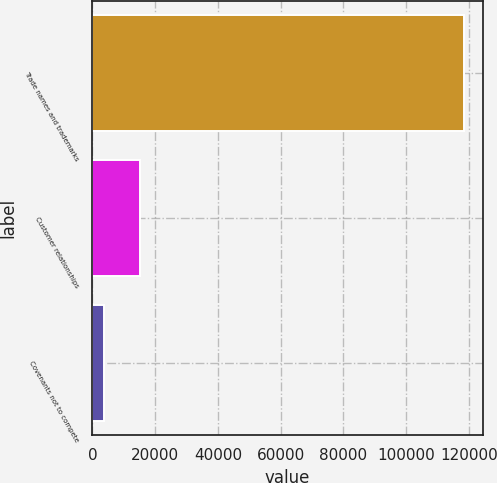<chart> <loc_0><loc_0><loc_500><loc_500><bar_chart><fcel>Trade names and trademarks<fcel>Customer relationships<fcel>Covenants not to compete<nl><fcel>118422<fcel>15130.8<fcel>3654<nl></chart> 